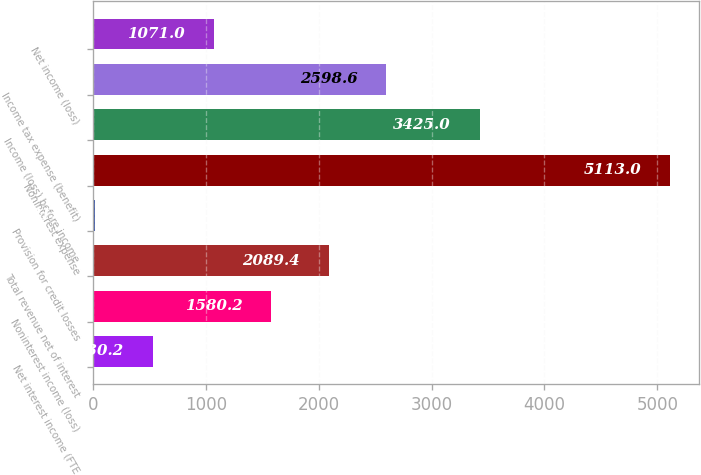<chart> <loc_0><loc_0><loc_500><loc_500><bar_chart><fcel>Net interest income (FTE<fcel>Noninterest income (loss)<fcel>Total revenue net of interest<fcel>Provision for credit losses<fcel>Noninterest expense<fcel>Income (loss) before income<fcel>Income tax expense (benefit)<fcel>Net income (loss)<nl><fcel>530.2<fcel>1580.2<fcel>2089.4<fcel>21<fcel>5113<fcel>3425<fcel>2598.6<fcel>1071<nl></chart> 